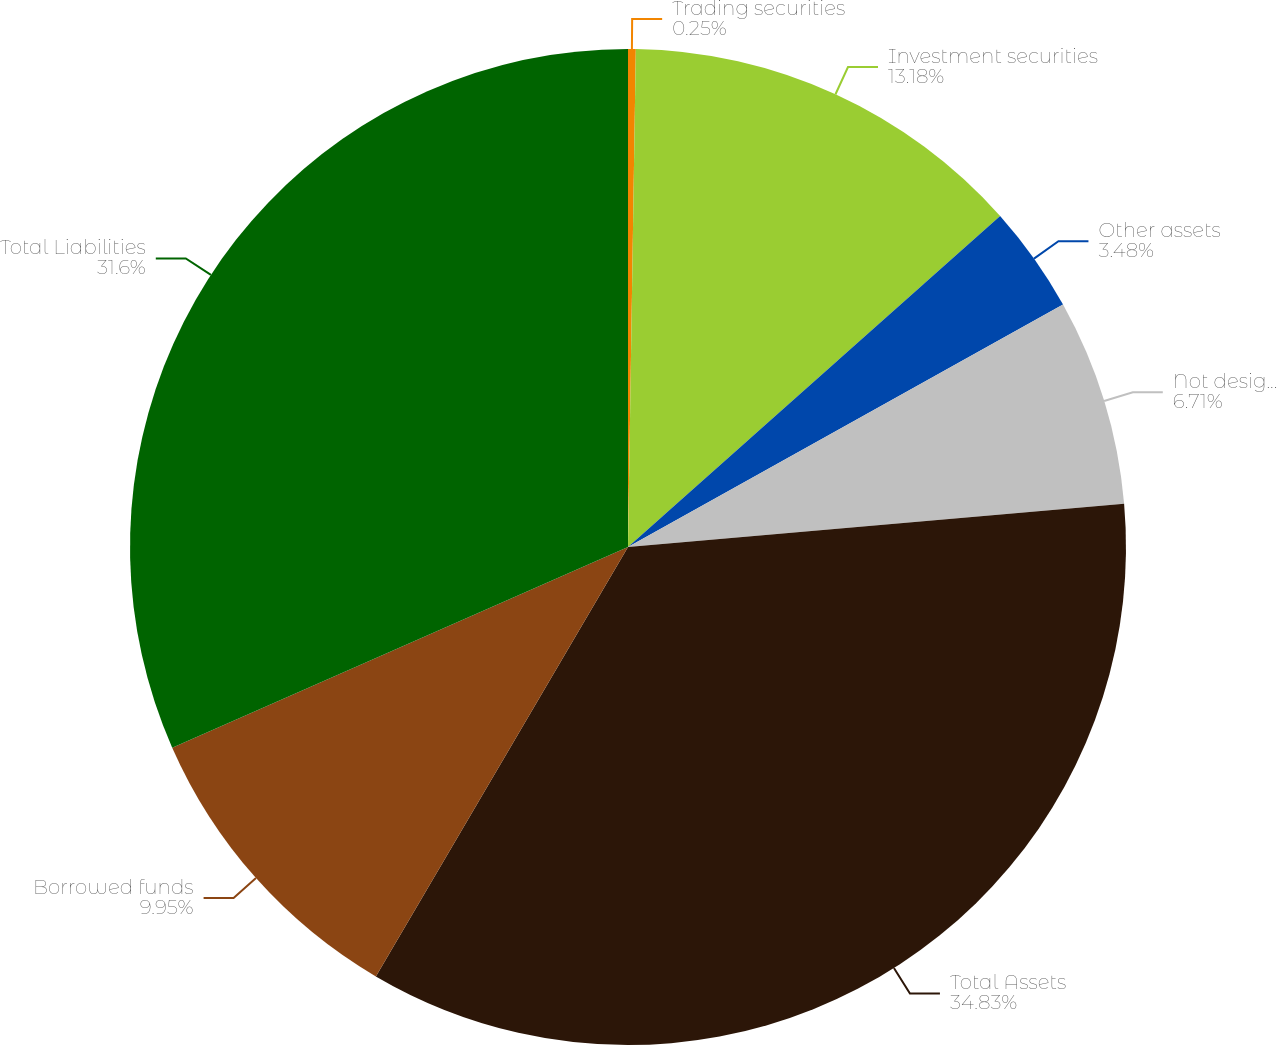Convert chart to OTSL. <chart><loc_0><loc_0><loc_500><loc_500><pie_chart><fcel>Trading securities<fcel>Investment securities<fcel>Other assets<fcel>Not designated as hedging<fcel>Total Assets<fcel>Borrowed funds<fcel>Total Liabilities<nl><fcel>0.25%<fcel>13.18%<fcel>3.48%<fcel>6.71%<fcel>34.83%<fcel>9.95%<fcel>31.6%<nl></chart> 